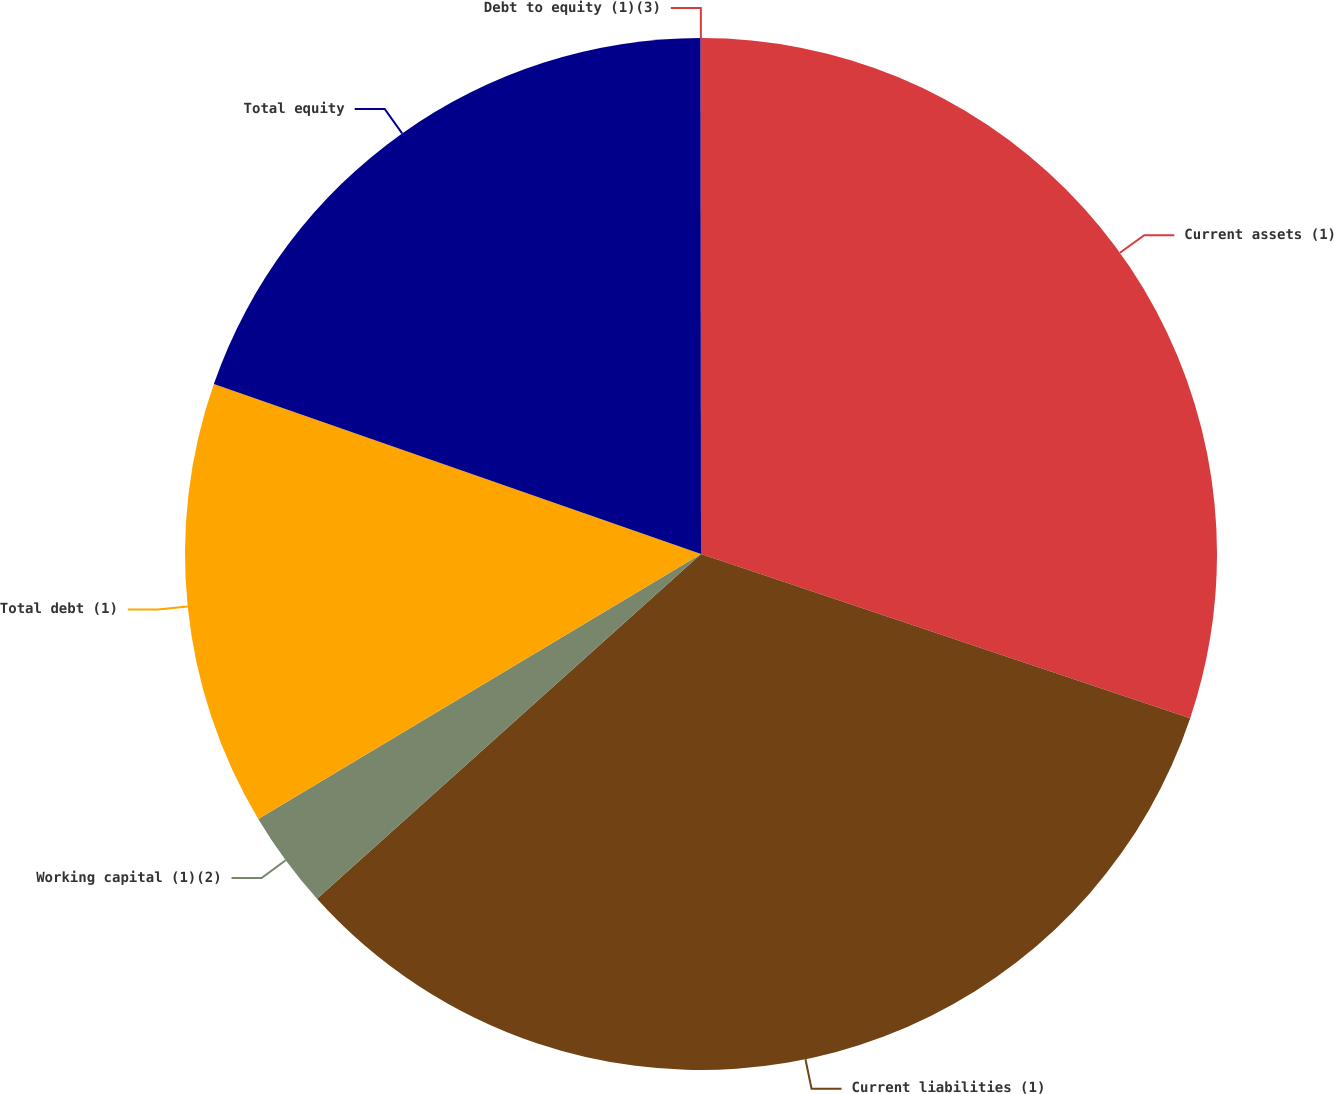Convert chart. <chart><loc_0><loc_0><loc_500><loc_500><pie_chart><fcel>Current assets (1)<fcel>Current liabilities (1)<fcel>Working capital (1)(2)<fcel>Total debt (1)<fcel>Total equity<fcel>Debt to equity (1)(3)<nl><fcel>30.16%<fcel>33.21%<fcel>3.06%<fcel>13.93%<fcel>19.65%<fcel>0.01%<nl></chart> 